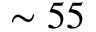Convert formula to latex. <formula><loc_0><loc_0><loc_500><loc_500>\sim 5 5</formula> 